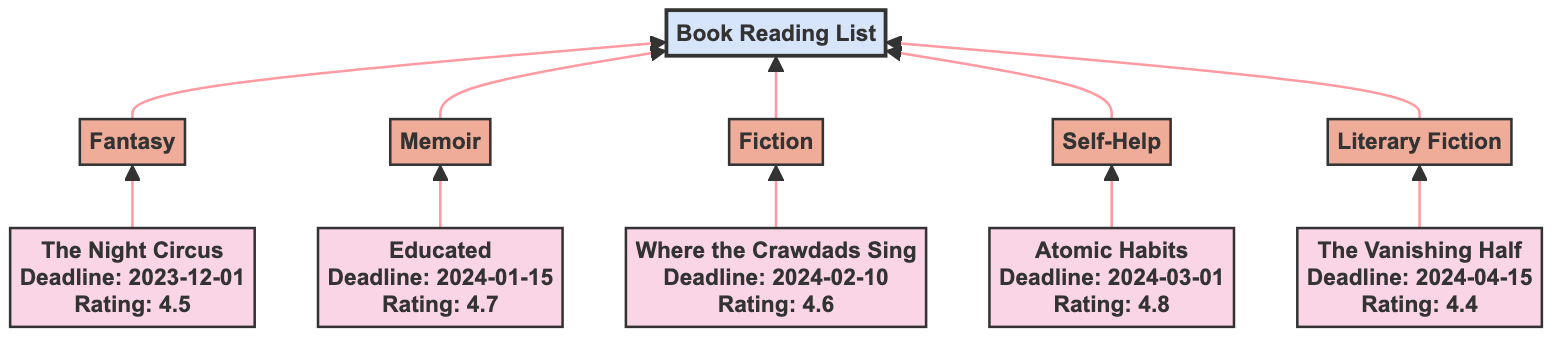What is the rating of "Atomic Habits"? According to the diagram, the title "Atomic Habits" displays a rating of 4.8. This information is shown directly next to the title node in the diagram.
Answer: 4.8 Which book has the earliest deadline? The book "The Night Circus" has a deadline of December 1, 2023, which is the earliest date listed compared to the other books in the diagram.
Answer: The Night Circus How many genres are listed in the diagram? There are five distinct genres represented in the bottom-up flow chart: Fantasy, Memoir, Fiction, Self-Help, and Literary Fiction. Each genre corresponds to one book title.
Answer: 5 What genre does "Where the Crawdads Sing" belong to? The diagram shows that "Where the Crawdads Sing" is linked to the genre "Fiction," indicating that this is its classification.
Answer: Fiction Which book has a deadline of April 15, 2024? The diagram indicates that "The Vanishing Half" has a deadline of April 15, 2024, as shown in the node details next to the title.
Answer: The Vanishing Half How many edges are connected to the "Book Reading List" node? Counting the connections leading into the "Book Reading List" node, there are five edges, one for each book title that links to the main category.
Answer: 5 What is the rating of "Educated"? The diagram lists the rating for "Educated" as 4.7, which is stated in the details associated with that title in the flow chart.
Answer: 4.7 Which book in the list falls under the genre "Self-Help"? The "Self-Help" genre is directly linked to the title "Atomic Habits," as shown in the diagram's structure.
Answer: Atomic Habits What is the most recent deadline among the listed books? The latest deadline in the diagram corresponds to "The Vanishing Half," which is due on April 15, 2024. This is later than the other listed deadlines.
Answer: The Vanishing Half 